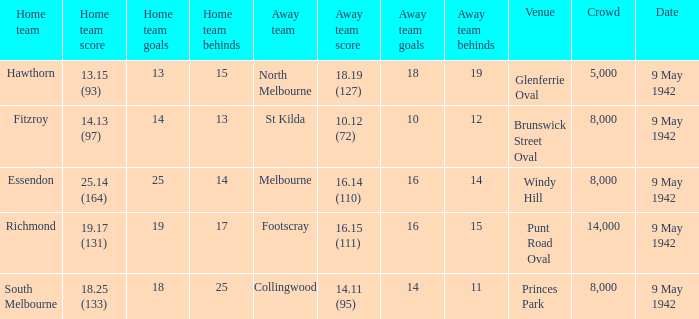How many people attended the game with the home team scoring 18.25 (133)? 1.0. 